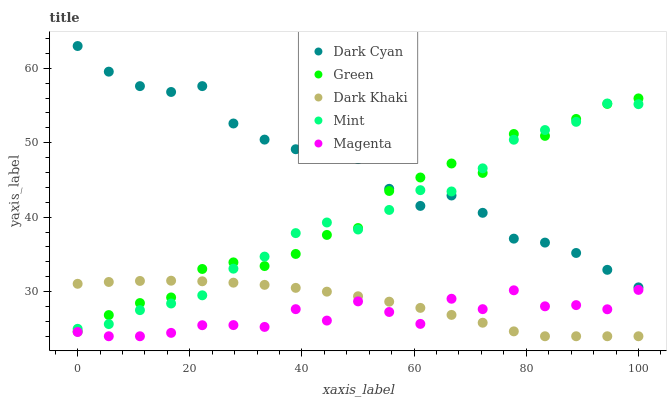Does Magenta have the minimum area under the curve?
Answer yes or no. Yes. Does Dark Cyan have the maximum area under the curve?
Answer yes or no. Yes. Does Dark Khaki have the minimum area under the curve?
Answer yes or no. No. Does Dark Khaki have the maximum area under the curve?
Answer yes or no. No. Is Dark Khaki the smoothest?
Answer yes or no. Yes. Is Magenta the roughest?
Answer yes or no. Yes. Is Magenta the smoothest?
Answer yes or no. No. Is Dark Khaki the roughest?
Answer yes or no. No. Does Dark Khaki have the lowest value?
Answer yes or no. Yes. Does Green have the lowest value?
Answer yes or no. No. Does Dark Cyan have the highest value?
Answer yes or no. Yes. Does Dark Khaki have the highest value?
Answer yes or no. No. Is Magenta less than Mint?
Answer yes or no. Yes. Is Dark Cyan greater than Dark Khaki?
Answer yes or no. Yes. Does Green intersect Mint?
Answer yes or no. Yes. Is Green less than Mint?
Answer yes or no. No. Is Green greater than Mint?
Answer yes or no. No. Does Magenta intersect Mint?
Answer yes or no. No. 